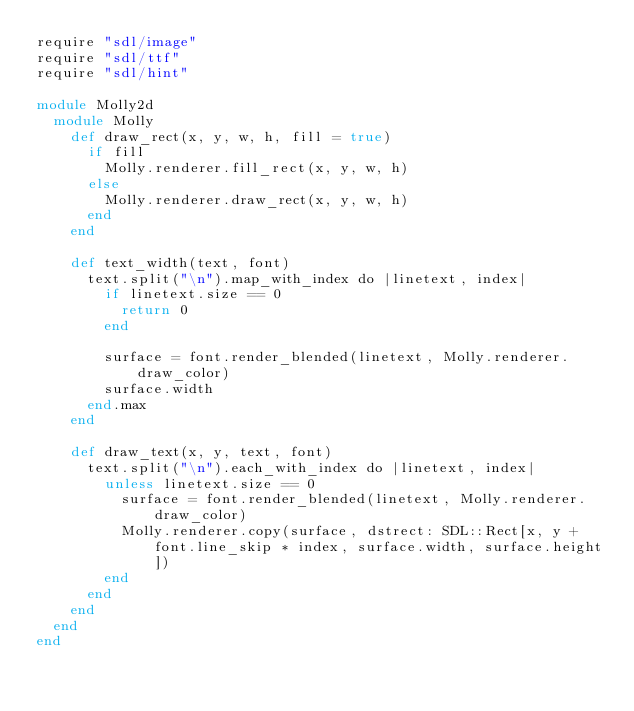Convert code to text. <code><loc_0><loc_0><loc_500><loc_500><_Crystal_>require "sdl/image"
require "sdl/ttf"
require "sdl/hint"

module Molly2d
  module Molly
    def draw_rect(x, y, w, h, fill = true)
      if fill
        Molly.renderer.fill_rect(x, y, w, h)
      else
        Molly.renderer.draw_rect(x, y, w, h)
      end
    end

    def text_width(text, font)
      text.split("\n").map_with_index do |linetext, index|
        if linetext.size == 0
          return 0
        end

        surface = font.render_blended(linetext, Molly.renderer.draw_color)
        surface.width
      end.max
    end

    def draw_text(x, y, text, font)
      text.split("\n").each_with_index do |linetext, index|
        unless linetext.size == 0
          surface = font.render_blended(linetext, Molly.renderer.draw_color)
          Molly.renderer.copy(surface, dstrect: SDL::Rect[x, y + font.line_skip * index, surface.width, surface.height])
        end
      end
    end
  end
end
</code> 